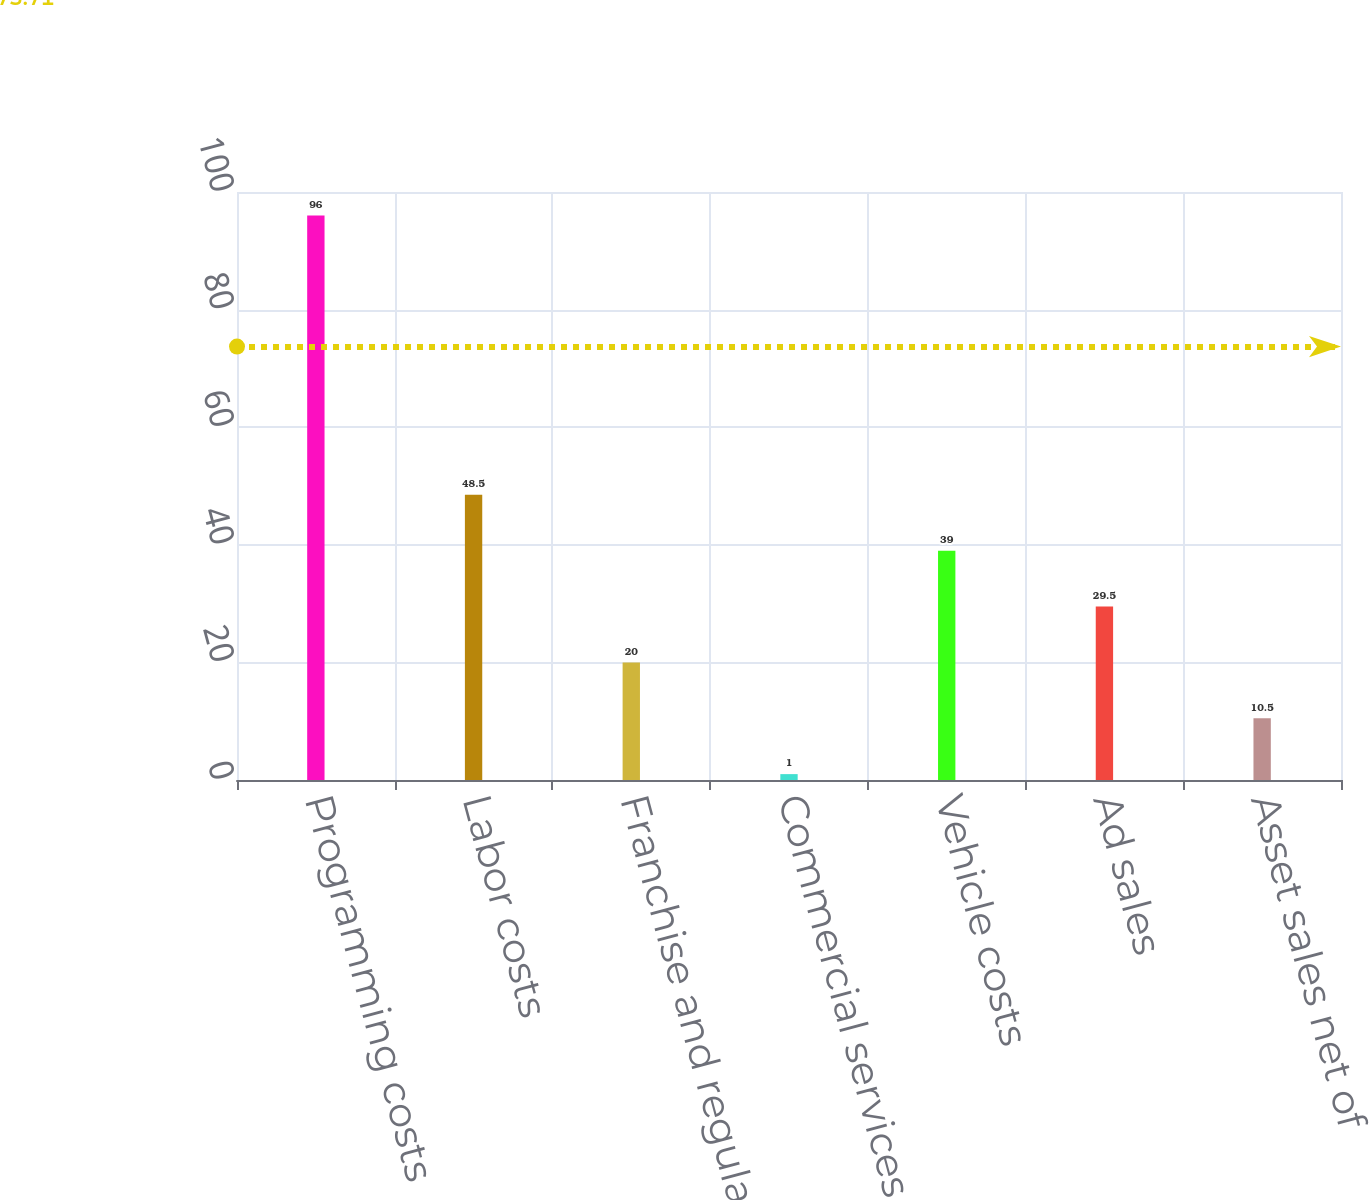<chart> <loc_0><loc_0><loc_500><loc_500><bar_chart><fcel>Programming costs<fcel>Labor costs<fcel>Franchise and regulatory fees<fcel>Commercial services<fcel>Vehicle costs<fcel>Ad sales<fcel>Asset sales net of<nl><fcel>96<fcel>48.5<fcel>20<fcel>1<fcel>39<fcel>29.5<fcel>10.5<nl></chart> 